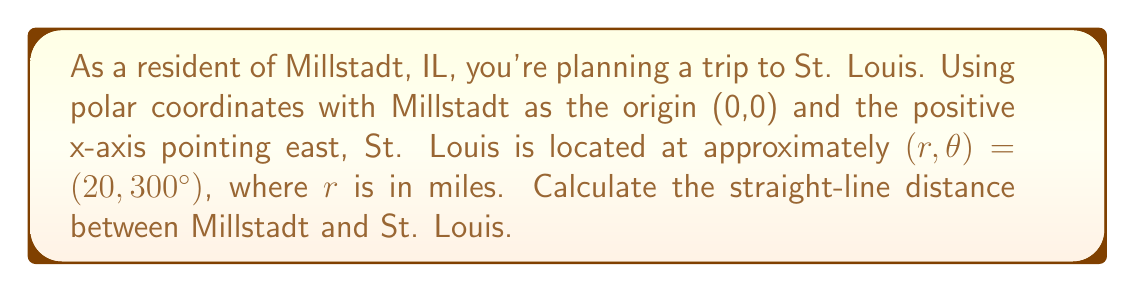Could you help me with this problem? To solve this problem, we'll use the given polar coordinates and convert them to Cartesian coordinates. Then, we can calculate the distance using the distance formula.

1. Convert polar coordinates to Cartesian coordinates:
   $x = r \cos(\theta)$
   $y = r \sin(\theta)$

   $x = 20 \cos(300°) = 20 \cdot (0.5) = 10$ miles
   $y = 20 \sin(300°) = 20 \cdot (-\frac{\sqrt{3}}{2}) = -10\sqrt{3}$ miles

   So, St. Louis is at $(10, -10\sqrt{3})$ in Cartesian coordinates.

2. Use the distance formula to calculate the straight-line distance:
   $$d = \sqrt{(x_2 - x_1)^2 + (y_2 - y_1)^2}$$

   Where $(x_1, y_1)$ is Millstadt (0,0) and $(x_2, y_2)$ is St. Louis $(10, -10\sqrt{3})$

   $$d = \sqrt{(10 - 0)^2 + (-10\sqrt{3} - 0)^2}$$
   $$d = \sqrt{100 + 300}$$
   $$d = \sqrt{400}$$
   $$d = 20$$ miles

3. Verify the result:
   The distance we calculated matches the original $r$ value in the polar coordinates, which is expected since $r$ represents the distance from the origin in polar form.
Answer: The straight-line distance between Millstadt, IL and St. Louis is 20 miles. 